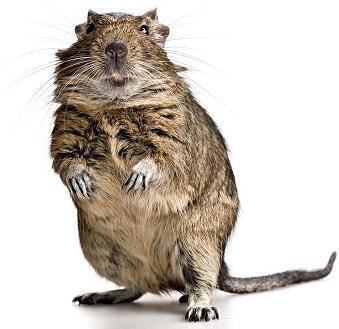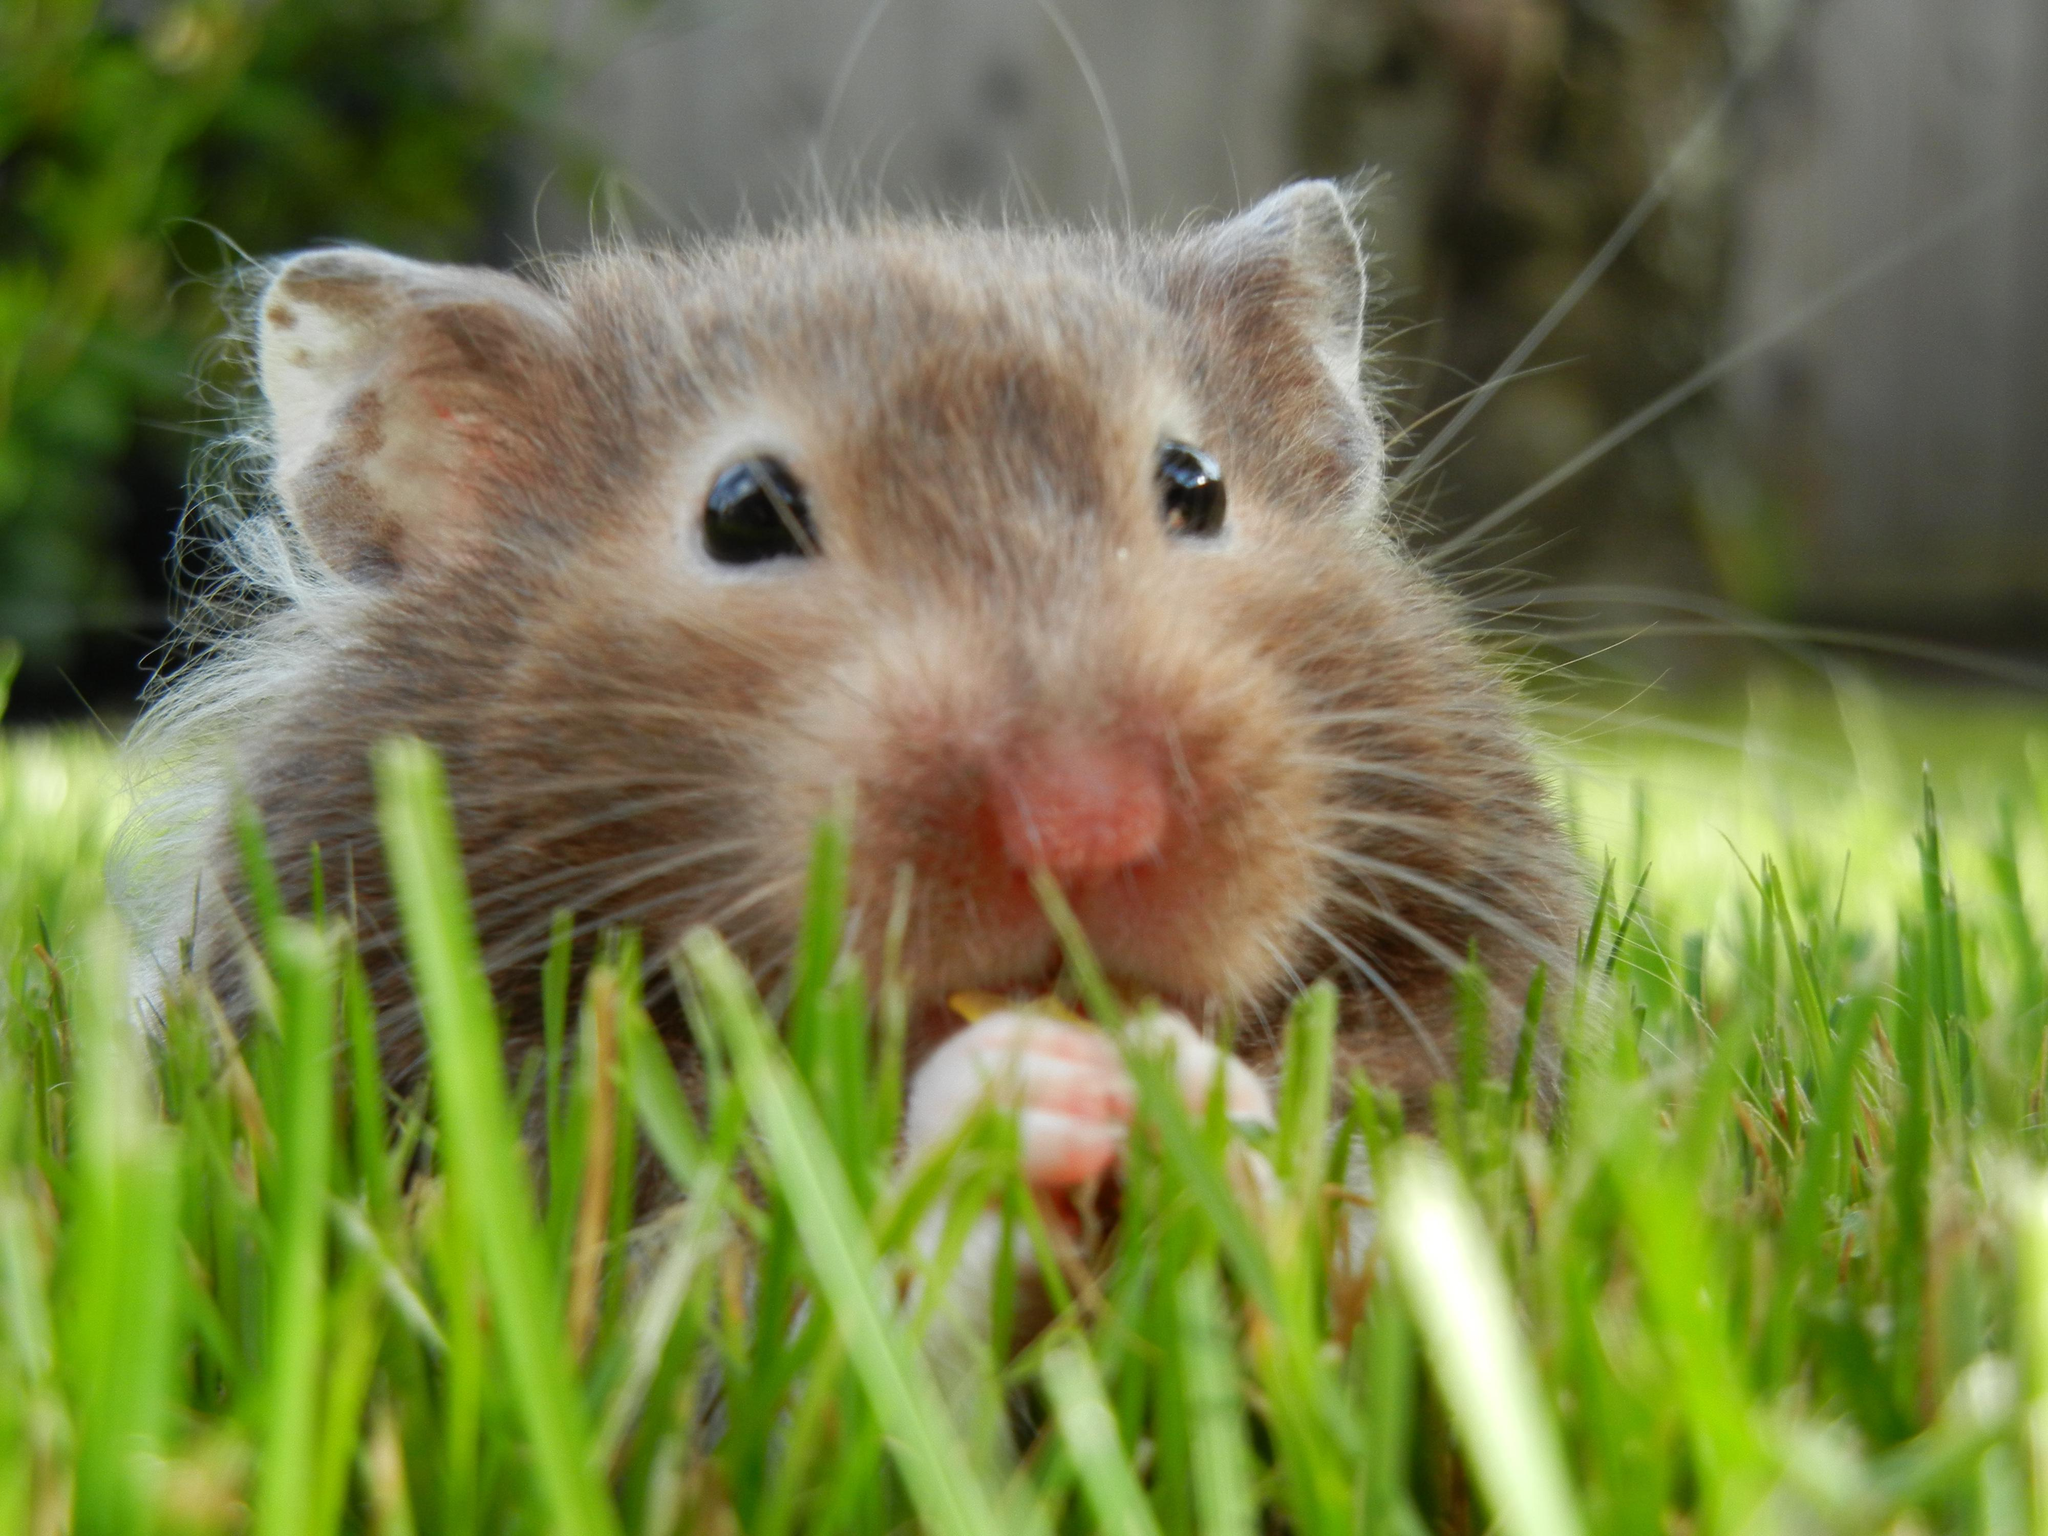The first image is the image on the left, the second image is the image on the right. For the images shown, is this caption "At least one of the rodents is outside." true? Answer yes or no. Yes. The first image is the image on the left, the second image is the image on the right. Examine the images to the left and right. Is the description "The image on the left shows a single rodent standing on its back legs." accurate? Answer yes or no. Yes. 